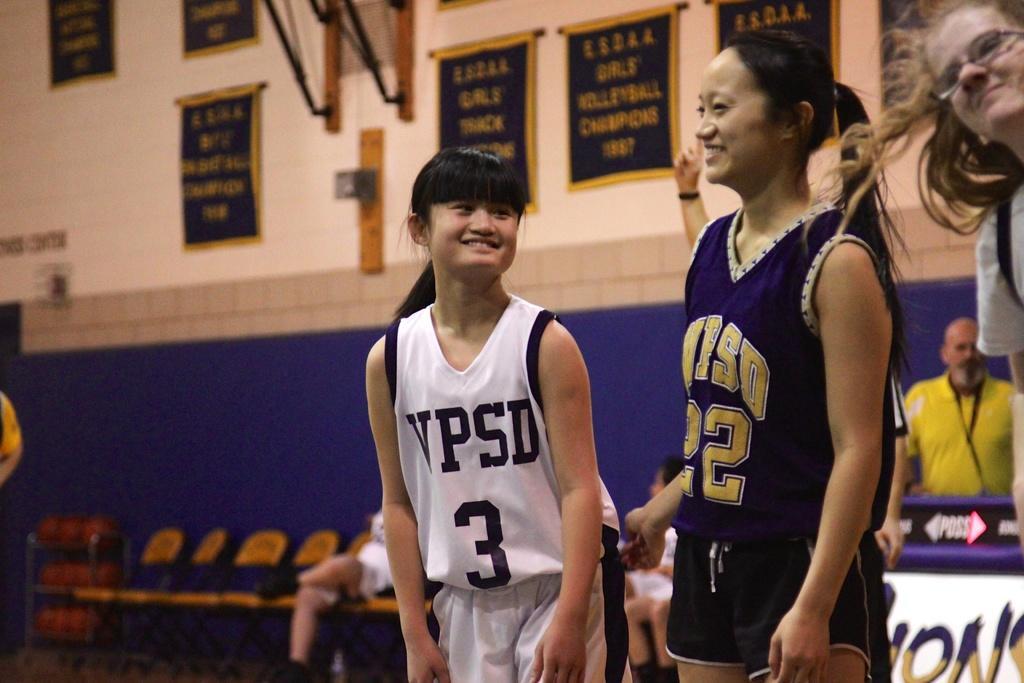Could you give a brief overview of what you see in this image? In the image there are two girls standing. On the right corner of the image there is a person with spectacles. Behind them there are chairs and there is a man behind the poster. In the background there is a wall with posters and wooden objects. 